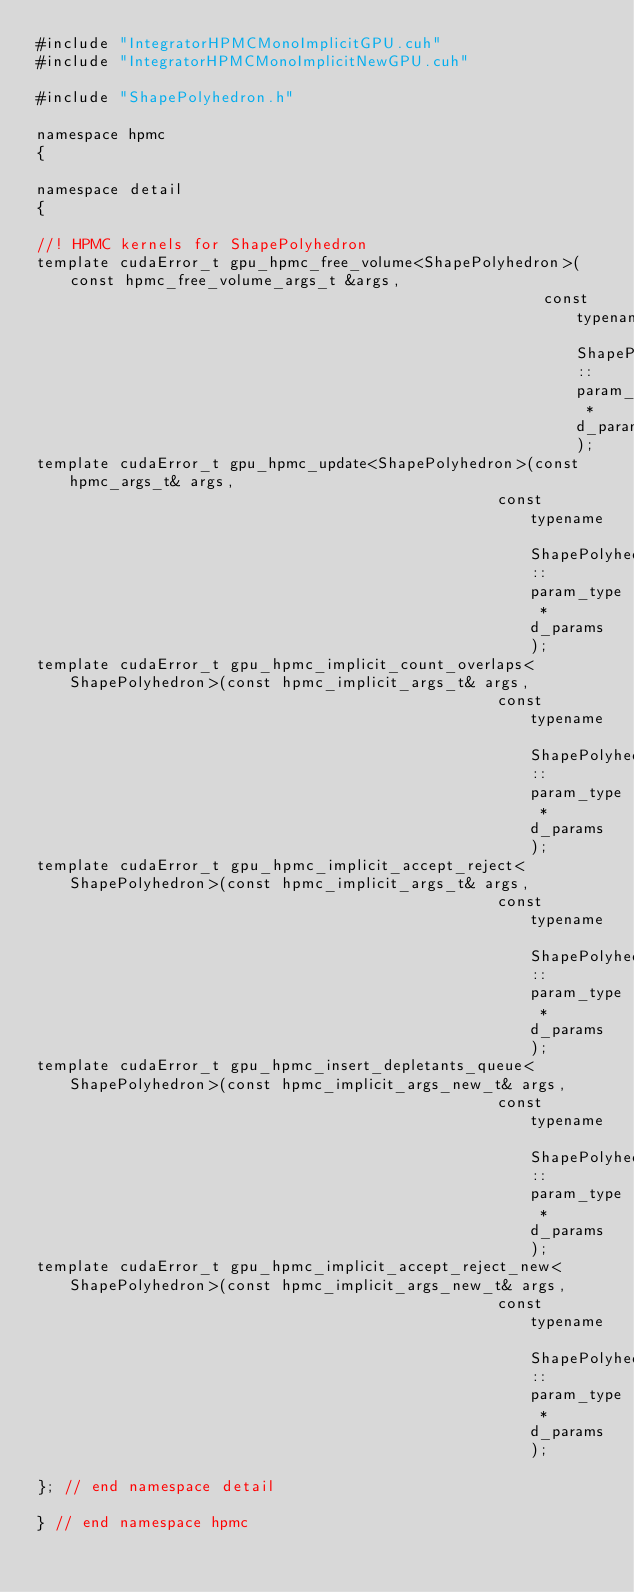Convert code to text. <code><loc_0><loc_0><loc_500><loc_500><_Cuda_>#include "IntegratorHPMCMonoImplicitGPU.cuh"
#include "IntegratorHPMCMonoImplicitNewGPU.cuh"

#include "ShapePolyhedron.h"

namespace hpmc
{

namespace detail
{

//! HPMC kernels for ShapePolyhedron
template cudaError_t gpu_hpmc_free_volume<ShapePolyhedron>(const hpmc_free_volume_args_t &args,
                                                       const typename ShapePolyhedron::param_type *d_params);
template cudaError_t gpu_hpmc_update<ShapePolyhedron>(const hpmc_args_t& args,
                                                  const typename ShapePolyhedron::param_type *d_params);
template cudaError_t gpu_hpmc_implicit_count_overlaps<ShapePolyhedron>(const hpmc_implicit_args_t& args,
                                                  const typename ShapePolyhedron::param_type *d_params);
template cudaError_t gpu_hpmc_implicit_accept_reject<ShapePolyhedron>(const hpmc_implicit_args_t& args,
                                                  const typename ShapePolyhedron::param_type *d_params);
template cudaError_t gpu_hpmc_insert_depletants_queue<ShapePolyhedron>(const hpmc_implicit_args_new_t& args,
                                                  const typename ShapePolyhedron::param_type *d_params);
template cudaError_t gpu_hpmc_implicit_accept_reject_new<ShapePolyhedron>(const hpmc_implicit_args_new_t& args,
                                                  const typename ShapePolyhedron::param_type *d_params);

}; // end namespace detail

} // end namespace hpmc
</code> 